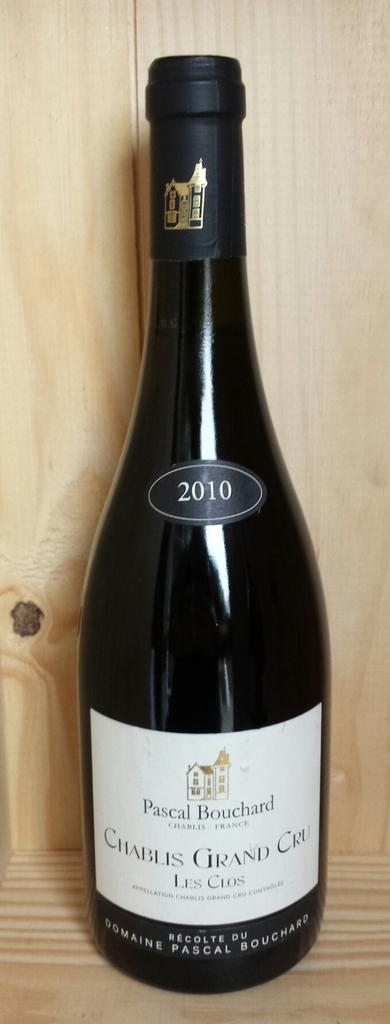What object can be seen in the image? There is a bottle in the image. What is the bottle placed on? The bottle is on a wooden surface. What is the color of the bottle? The bottle is black in color. Is there any text or design on the bottle? Yes, there is a white label on the bottle. How many babies are wearing dresses in the image? There are no babies or dresses present in the image; it features a black bottle with a white label on a wooden surface. What type of hydrant is visible in the image? There is no hydrant present in the image. 